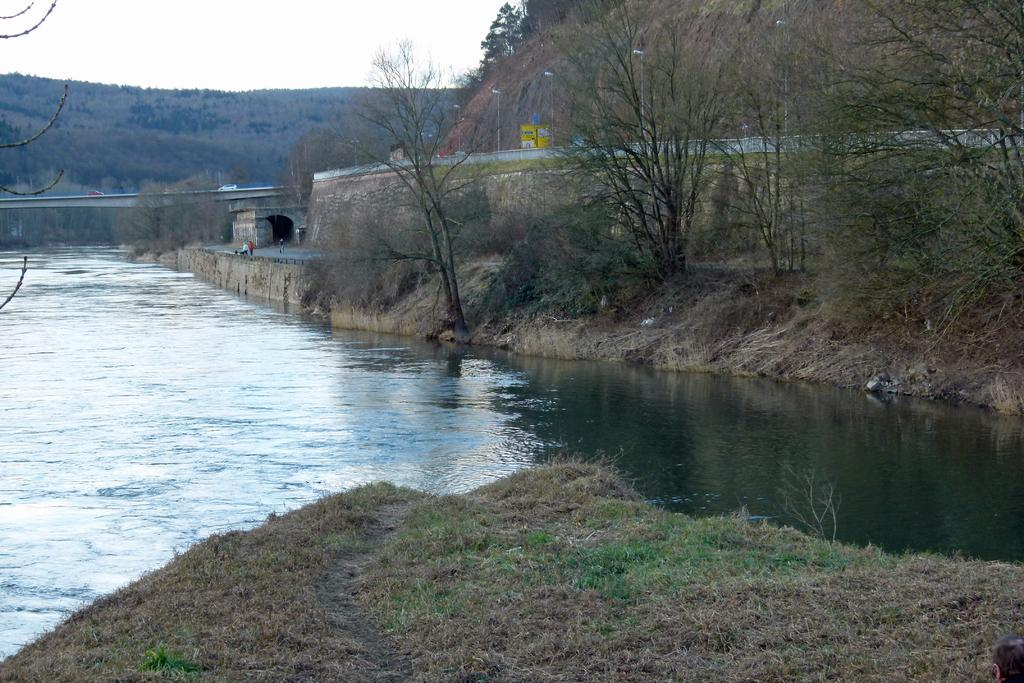What type of natural environment is depicted in the image? The image contains grass, water, trees, and mountains, which are all elements of a natural environment. What structures can be seen in the image? There are poles and an arch visible in the image. What is the condition of the sky in the image? The sky is visible in the background of the image. Are there any people present in the image? Yes, there are people on the road in the image. What type of stew is being served at the picnic in the image? There is no picnic or stew present in the image. Can you tell me how many gloves are visible in the image? There are no gloves present in the image. 